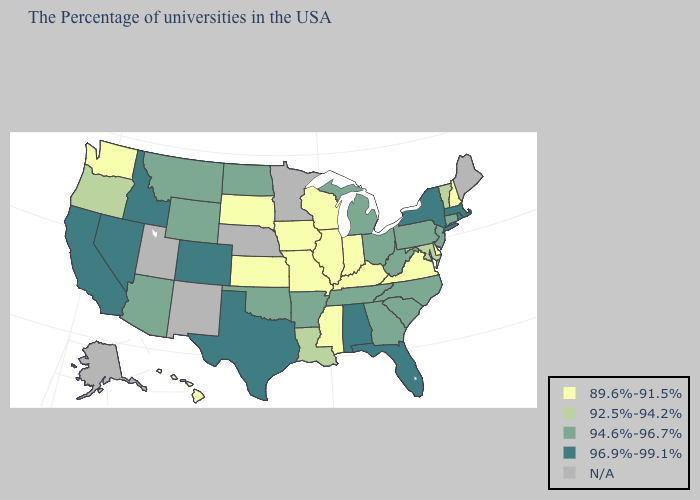What is the lowest value in the USA?
Short answer required. 89.6%-91.5%. What is the value of Montana?
Short answer required. 94.6%-96.7%. Does Colorado have the highest value in the West?
Quick response, please. Yes. What is the lowest value in states that border Arkansas?
Keep it brief. 89.6%-91.5%. Does Oregon have the lowest value in the West?
Give a very brief answer. No. Name the states that have a value in the range 96.9%-99.1%?
Quick response, please. Massachusetts, Rhode Island, New York, Florida, Alabama, Texas, Colorado, Idaho, Nevada, California. What is the highest value in the USA?
Answer briefly. 96.9%-99.1%. Which states hav the highest value in the West?
Write a very short answer. Colorado, Idaho, Nevada, California. What is the lowest value in the MidWest?
Concise answer only. 89.6%-91.5%. What is the lowest value in the USA?
Quick response, please. 89.6%-91.5%. Among the states that border Louisiana , which have the lowest value?
Answer briefly. Mississippi. Name the states that have a value in the range 92.5%-94.2%?
Quick response, please. Vermont, Maryland, Louisiana, Oregon. Which states hav the highest value in the MidWest?
Be succinct. Ohio, Michigan, North Dakota. Does Nevada have the highest value in the USA?
Be succinct. Yes. What is the value of Mississippi?
Answer briefly. 89.6%-91.5%. 